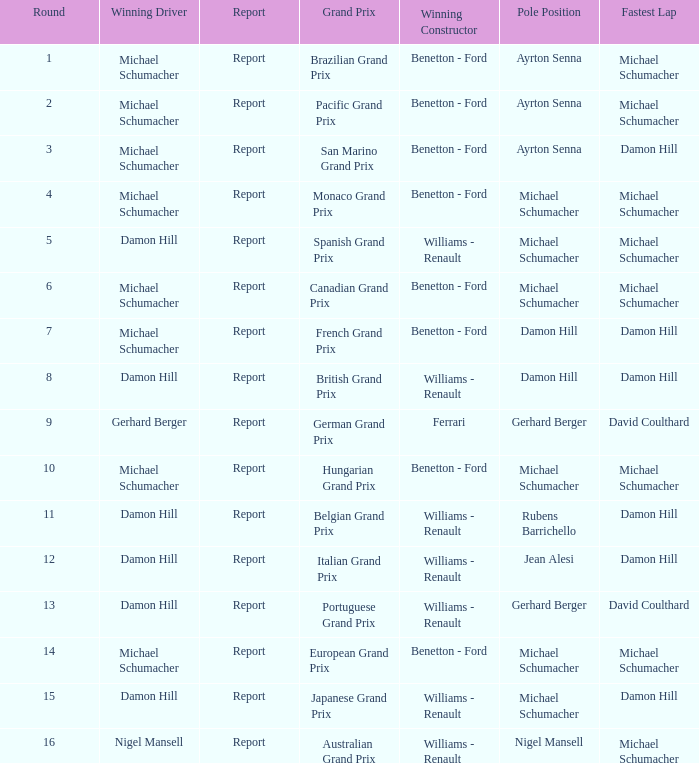Name the pole position at the japanese grand prix when the fastest lap is damon hill Michael Schumacher. Give me the full table as a dictionary. {'header': ['Round', 'Winning Driver', 'Report', 'Grand Prix', 'Winning Constructor', 'Pole Position', 'Fastest Lap'], 'rows': [['1', 'Michael Schumacher', 'Report', 'Brazilian Grand Prix', 'Benetton - Ford', 'Ayrton Senna', 'Michael Schumacher'], ['2', 'Michael Schumacher', 'Report', 'Pacific Grand Prix', 'Benetton - Ford', 'Ayrton Senna', 'Michael Schumacher'], ['3', 'Michael Schumacher', 'Report', 'San Marino Grand Prix', 'Benetton - Ford', 'Ayrton Senna', 'Damon Hill'], ['4', 'Michael Schumacher', 'Report', 'Monaco Grand Prix', 'Benetton - Ford', 'Michael Schumacher', 'Michael Schumacher'], ['5', 'Damon Hill', 'Report', 'Spanish Grand Prix', 'Williams - Renault', 'Michael Schumacher', 'Michael Schumacher'], ['6', 'Michael Schumacher', 'Report', 'Canadian Grand Prix', 'Benetton - Ford', 'Michael Schumacher', 'Michael Schumacher'], ['7', 'Michael Schumacher', 'Report', 'French Grand Prix', 'Benetton - Ford', 'Damon Hill', 'Damon Hill'], ['8', 'Damon Hill', 'Report', 'British Grand Prix', 'Williams - Renault', 'Damon Hill', 'Damon Hill'], ['9', 'Gerhard Berger', 'Report', 'German Grand Prix', 'Ferrari', 'Gerhard Berger', 'David Coulthard'], ['10', 'Michael Schumacher', 'Report', 'Hungarian Grand Prix', 'Benetton - Ford', 'Michael Schumacher', 'Michael Schumacher'], ['11', 'Damon Hill', 'Report', 'Belgian Grand Prix', 'Williams - Renault', 'Rubens Barrichello', 'Damon Hill'], ['12', 'Damon Hill', 'Report', 'Italian Grand Prix', 'Williams - Renault', 'Jean Alesi', 'Damon Hill'], ['13', 'Damon Hill', 'Report', 'Portuguese Grand Prix', 'Williams - Renault', 'Gerhard Berger', 'David Coulthard'], ['14', 'Michael Schumacher', 'Report', 'European Grand Prix', 'Benetton - Ford', 'Michael Schumacher', 'Michael Schumacher'], ['15', 'Damon Hill', 'Report', 'Japanese Grand Prix', 'Williams - Renault', 'Michael Schumacher', 'Damon Hill'], ['16', 'Nigel Mansell', 'Report', 'Australian Grand Prix', 'Williams - Renault', 'Nigel Mansell', 'Michael Schumacher']]} 